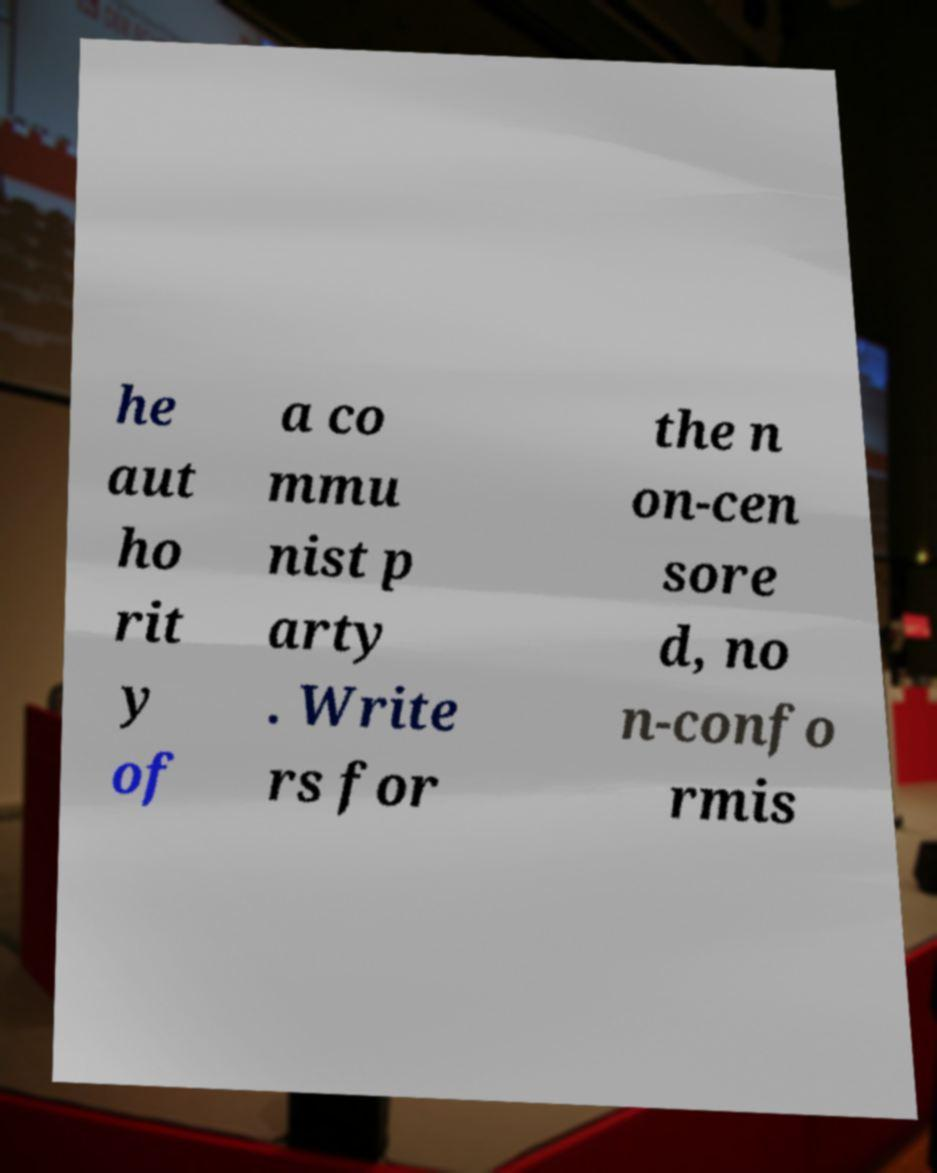What messages or text are displayed in this image? I need them in a readable, typed format. he aut ho rit y of a co mmu nist p arty . Write rs for the n on-cen sore d, no n-confo rmis 